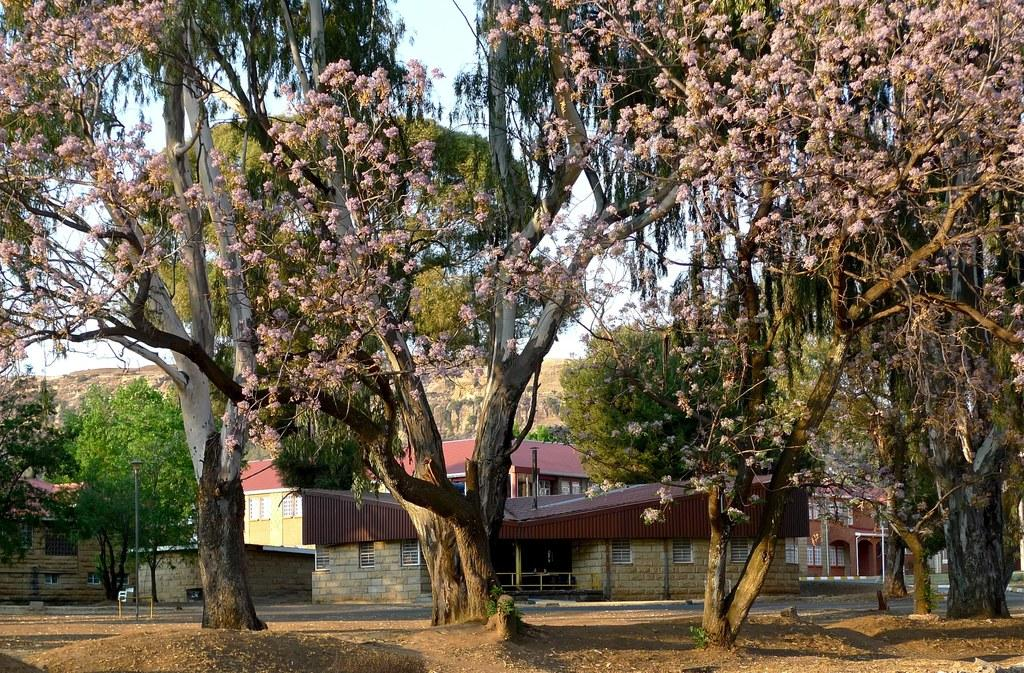What type of natural elements can be seen in the image? There are trees in the image. What type of man-made structures are present in the image? There are houses in the image. What geographical feature is visible in the image? There is a hill in the image. What is visible above the houses and trees in the image? The sky is visible in the image. Can you tell me where your uncle is walking in the image? There is no uncle or walking activity present in the image. What type of vest is hanging on the trees in the image? There are no vests present in the image; it features trees, houses, a hill, and the sky. 